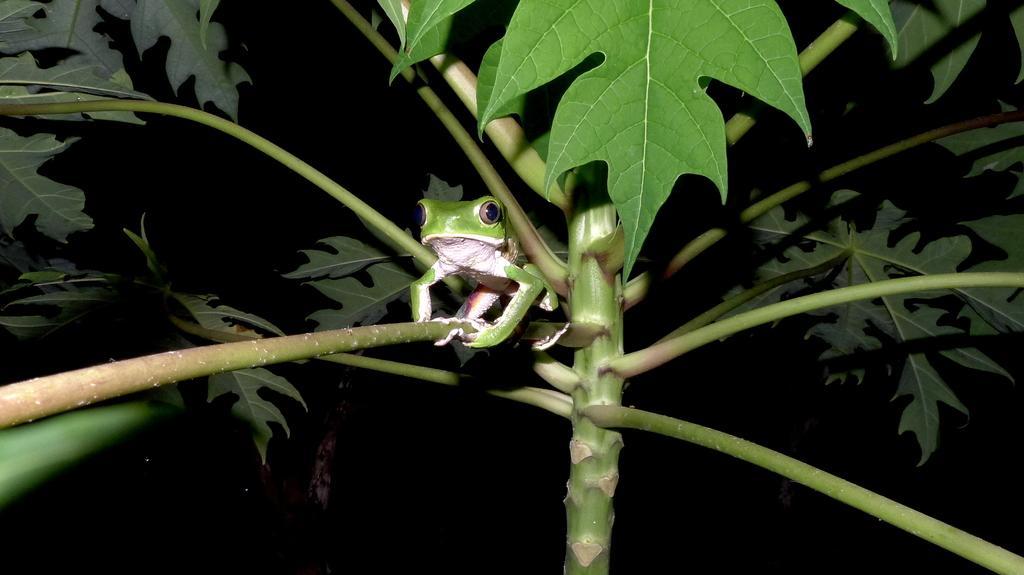Could you give a brief overview of what you see in this image? In this image there is a plant. There is a frog on the plant. The background is dark. 